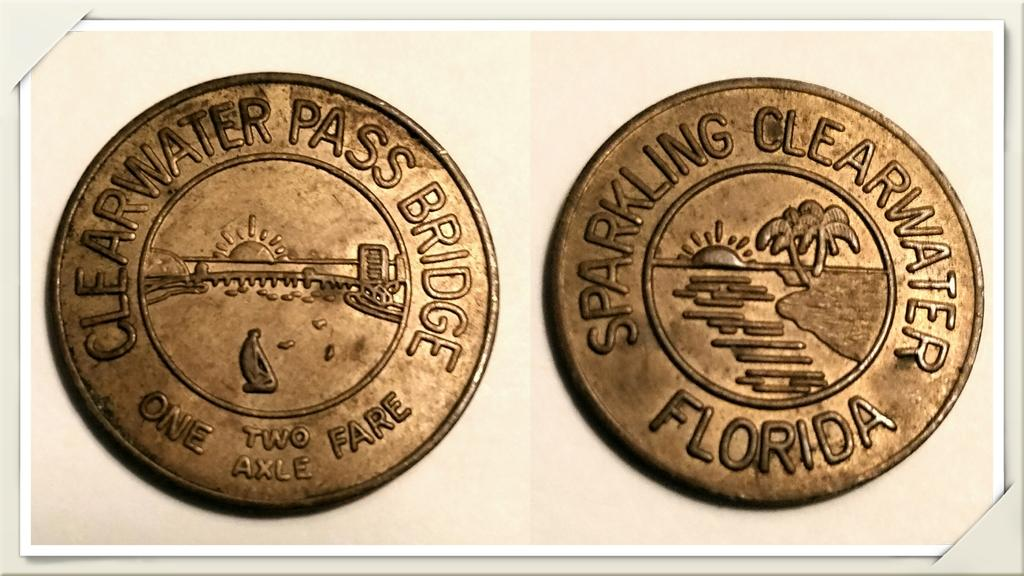Provide a one-sentence caption for the provided image. Clearwater Pass Bridge, Sparkling Clearwater Florida is etched onto these two coins. 